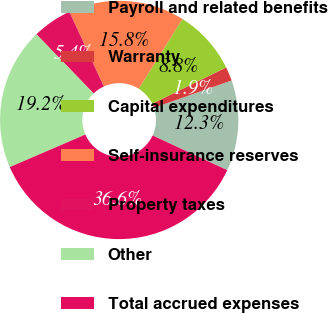Convert chart. <chart><loc_0><loc_0><loc_500><loc_500><pie_chart><fcel>Payroll and related benefits<fcel>Warranty<fcel>Capital expenditures<fcel>Self-insurance reserves<fcel>Property taxes<fcel>Other<fcel>Total accrued expenses<nl><fcel>12.3%<fcel>1.89%<fcel>8.83%<fcel>15.77%<fcel>5.36%<fcel>19.24%<fcel>36.6%<nl></chart> 